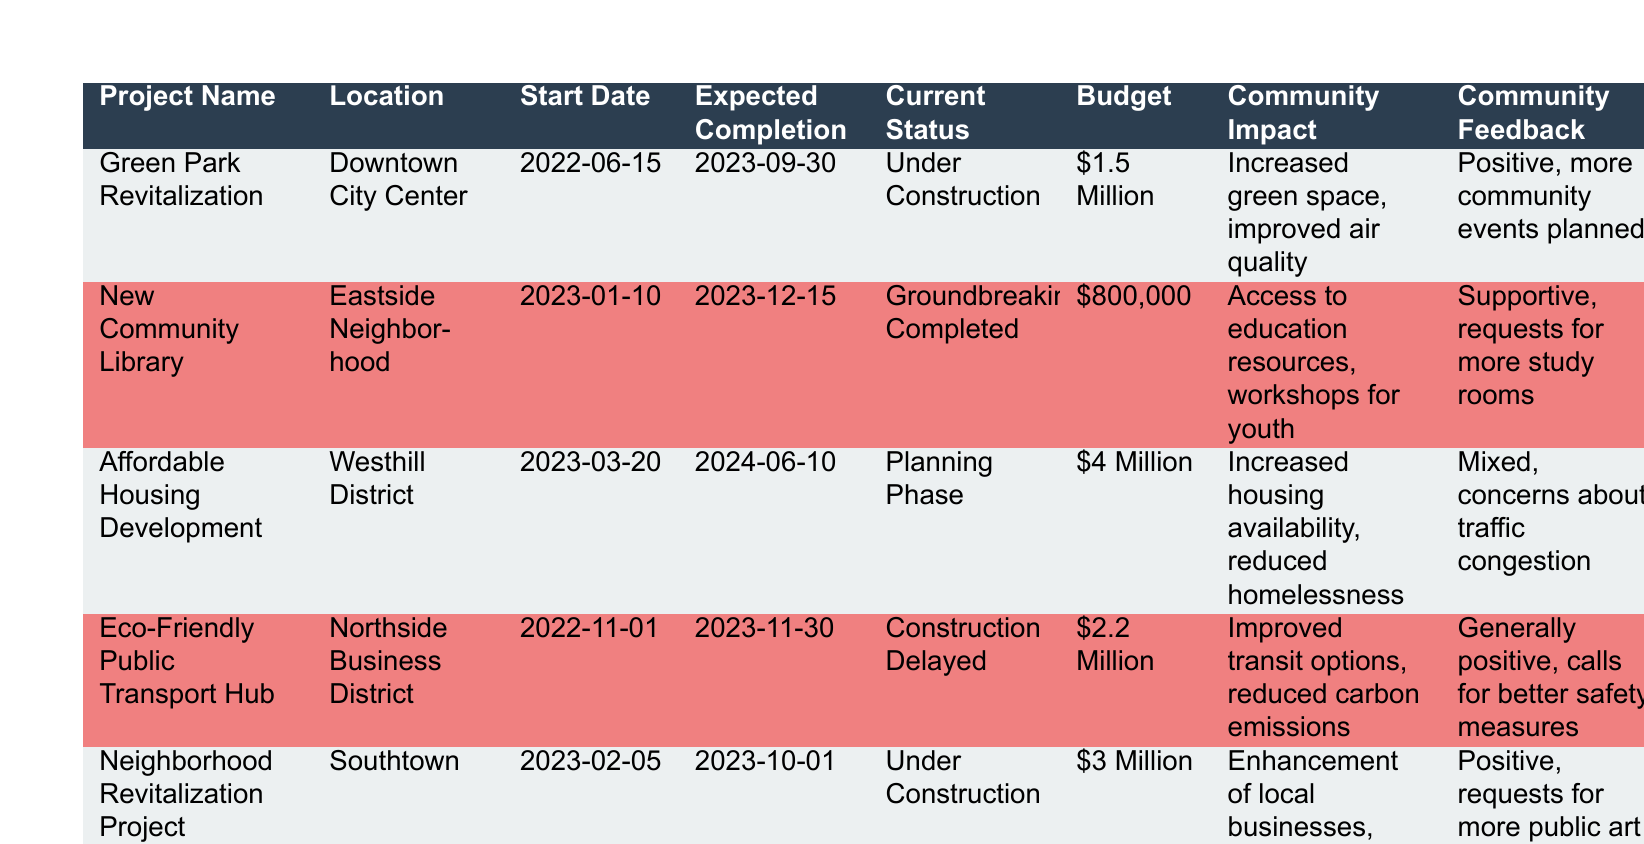What's the current status of the "Affordable Housing Development"? According to the table, the current status for the "Affordable Housing Development" is listed as "Planning Phase".
Answer: Planning Phase Which project has the highest budget? The "Affordable Housing Development" has the highest budget of four million dollars compared to the rest of the projects listed.
Answer: Four million dollars What is the expected completion date for the "Green Park Revitalization"? The expected completion date for the "Green Park Revitalization" is September 30, 2023, as indicated in the table.
Answer: September 30, 2023 Is the community feedback for the "Eco-Friendly Public Transport Hub" generally positive? Yes, the community feedback for the "Eco-Friendly Public Transport Hub" is noted as "generally positive, calls for better safety measures", indicating an overall favorable response.
Answer: Yes How many projects are currently under construction? There are three projects currently under construction, which are the "Green Park Revitalization", "Neighborhood Revitalization Project", and "Eco-Friendly Public Transport Hub".
Answer: Three What is the total budget for all listed projects? The total budget is calculated by adding the budgets of all projects: 1.5 million + 0.8 million + 4 million + 2.2 million + 3 million = 11.5 million dollars.
Answer: Eleven point five million dollars Which project is set to be completed first? The "Green Park Revitalization" is set to be completed first, with an expected completion date of September 30, 2023, compared to other projects.
Answer: Green Park Revitalization What community impact is associated with the "New Community Library"? The community impact associated with the "New Community Library" is increased access to education resources and workshops for youth, as outlined in the table.
Answer: Increased access to education resources and workshops for youth Are there any projects located in Downtown City Center? Yes, the "Green Park Revitalization" is located in Downtown City Center, as per the location information in the table.
Answer: Yes 